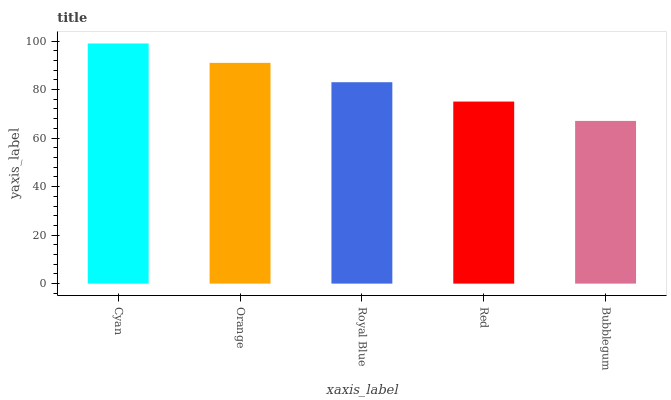Is Bubblegum the minimum?
Answer yes or no. Yes. Is Cyan the maximum?
Answer yes or no. Yes. Is Orange the minimum?
Answer yes or no. No. Is Orange the maximum?
Answer yes or no. No. Is Cyan greater than Orange?
Answer yes or no. Yes. Is Orange less than Cyan?
Answer yes or no. Yes. Is Orange greater than Cyan?
Answer yes or no. No. Is Cyan less than Orange?
Answer yes or no. No. Is Royal Blue the high median?
Answer yes or no. Yes. Is Royal Blue the low median?
Answer yes or no. Yes. Is Red the high median?
Answer yes or no. No. Is Bubblegum the low median?
Answer yes or no. No. 